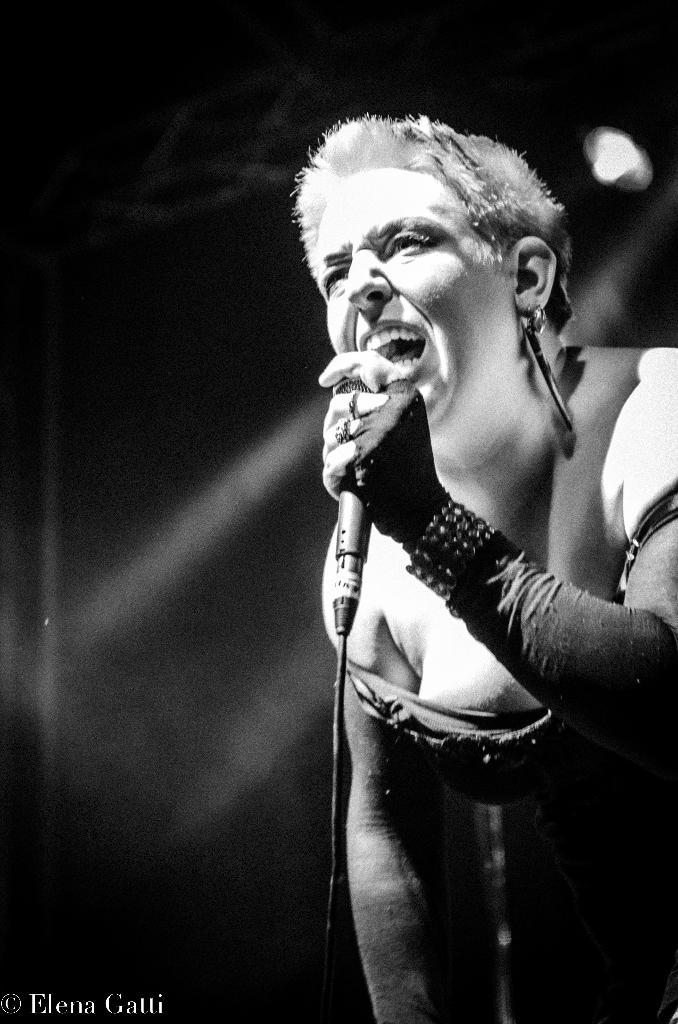What is the woman in the picture doing? The woman is singing. What object is the woman holding while singing? The woman is holding a microphone. Can you identify any text in the image? Yes, there is a watermark in the bottom left corner of the image that reads "Elena Galli". What type of bead is the snail wearing on its shell in the image? There is no snail or bead present in the image; it features a woman singing with a microphone. 